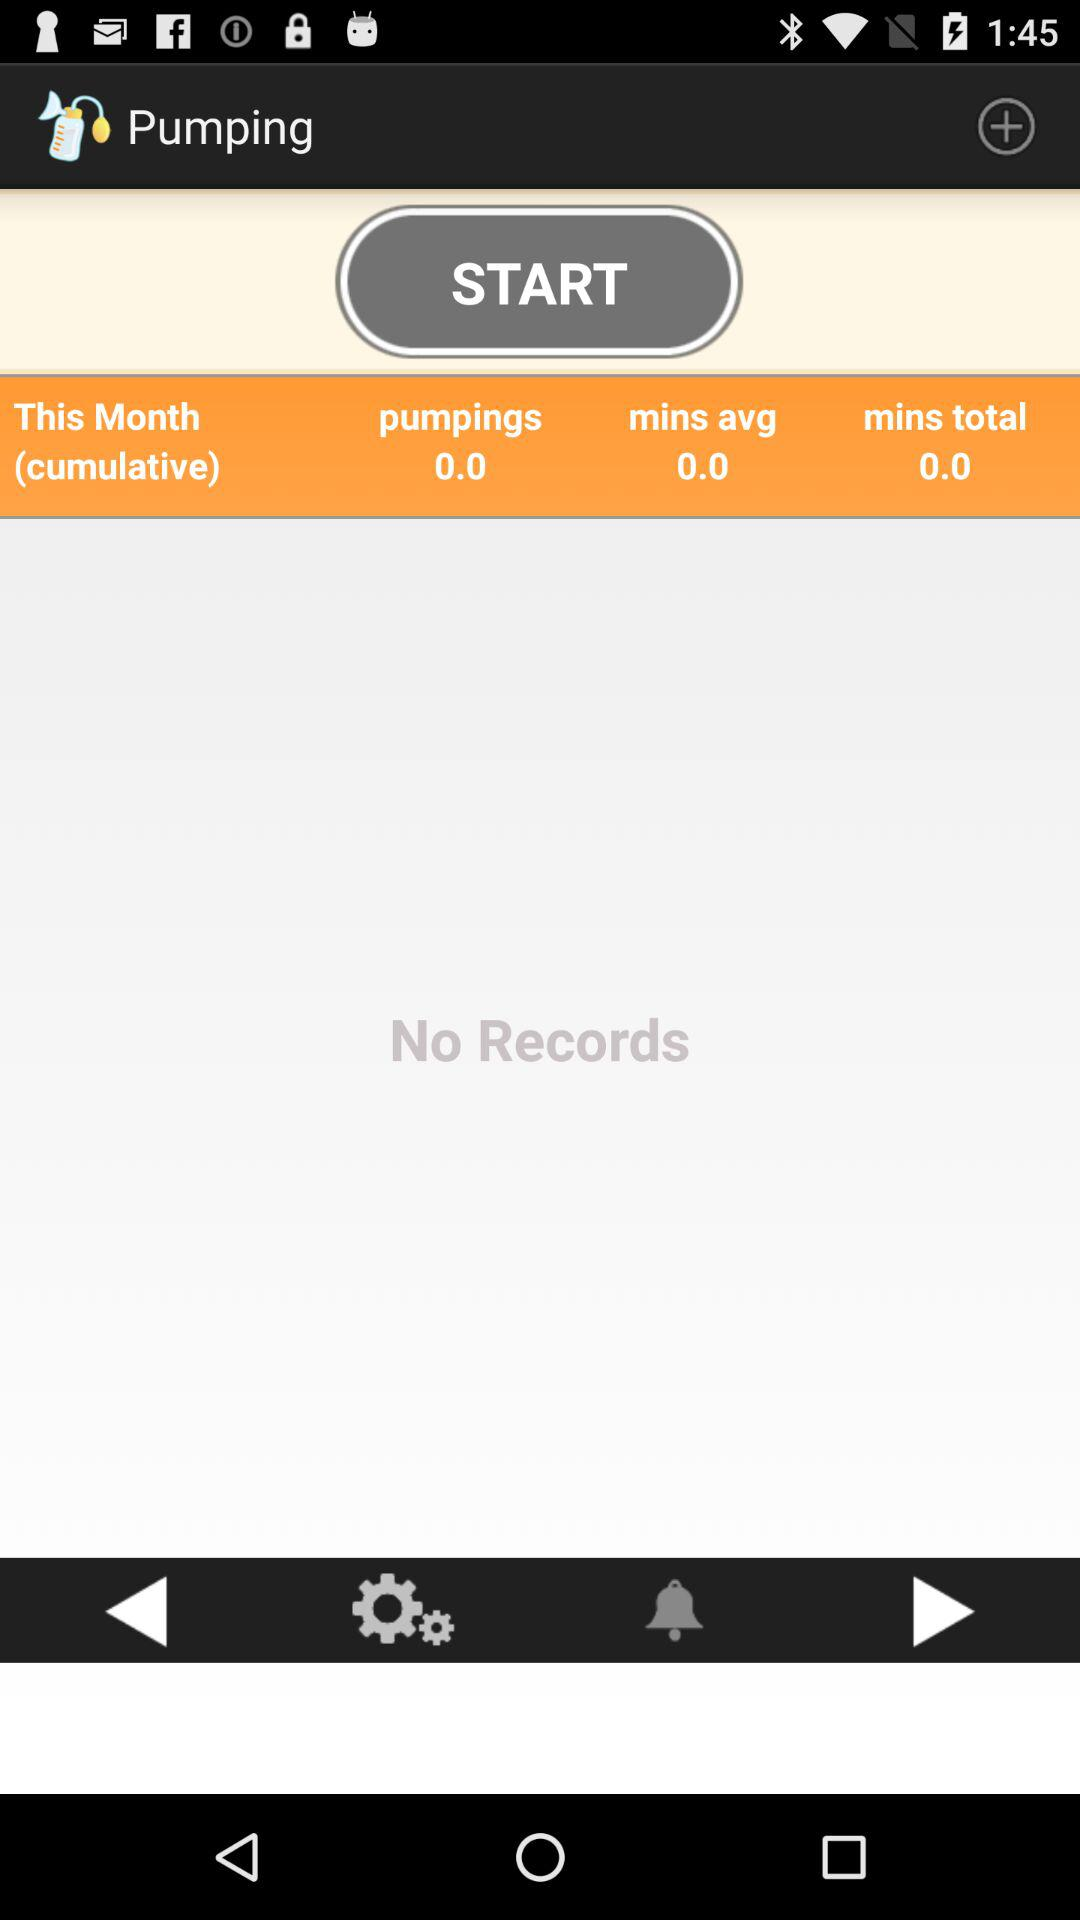What is the duration of the "pumpings" of this month? The duration of the "pumpings" is 0.0. 